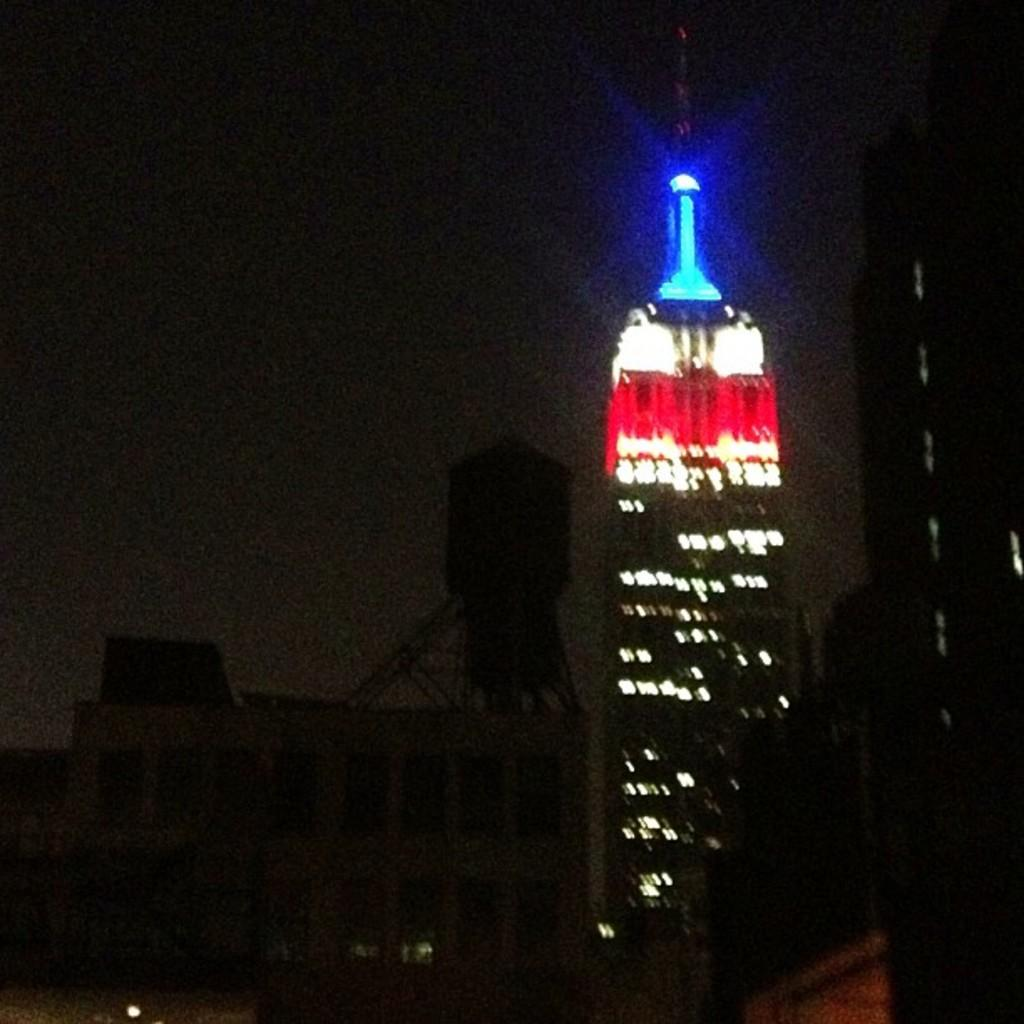What time of day is the image taken? The image is taken at night. What type of structure can be seen in the background of the image? There are lights visible from a skyscraper in the background. How would you describe the color of the sky in the image? The sky is dark in the image. What type of flowers can be seen growing near the building in the image? There are no flowers visible in the image; it is taken at night and focuses on a skyscraper with lights. What flavor of mint is being used to garnish the dish in the image? There is no dish or mint present in the image. 